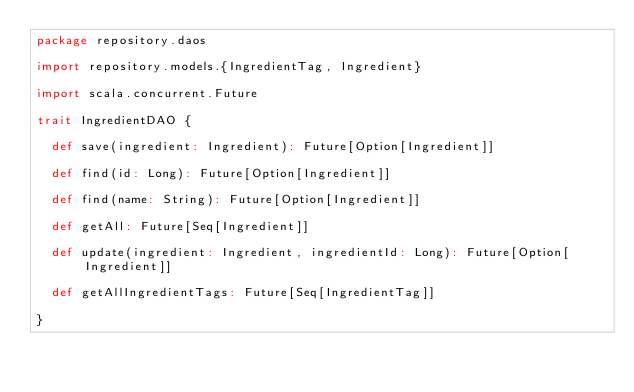Convert code to text. <code><loc_0><loc_0><loc_500><loc_500><_Scala_>package repository.daos

import repository.models.{IngredientTag, Ingredient}

import scala.concurrent.Future

trait IngredientDAO {

  def save(ingredient: Ingredient): Future[Option[Ingredient]]

  def find(id: Long): Future[Option[Ingredient]]

  def find(name: String): Future[Option[Ingredient]]

  def getAll: Future[Seq[Ingredient]]

  def update(ingredient: Ingredient, ingredientId: Long): Future[Option[Ingredient]]

  def getAllIngredientTags: Future[Seq[IngredientTag]]

}
</code> 